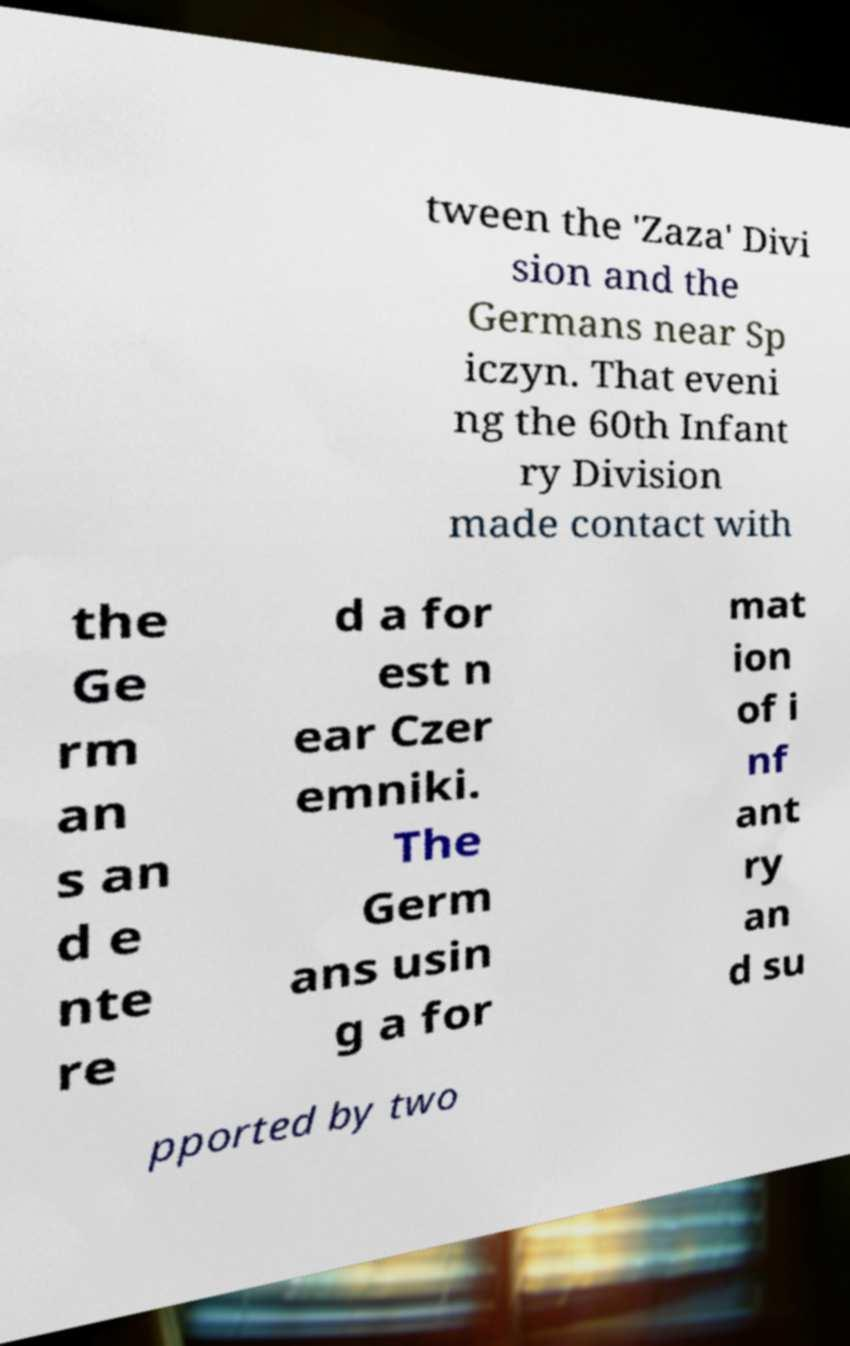There's text embedded in this image that I need extracted. Can you transcribe it verbatim? tween the 'Zaza' Divi sion and the Germans near Sp iczyn. That eveni ng the 60th Infant ry Division made contact with the Ge rm an s an d e nte re d a for est n ear Czer emniki. The Germ ans usin g a for mat ion of i nf ant ry an d su pported by two 